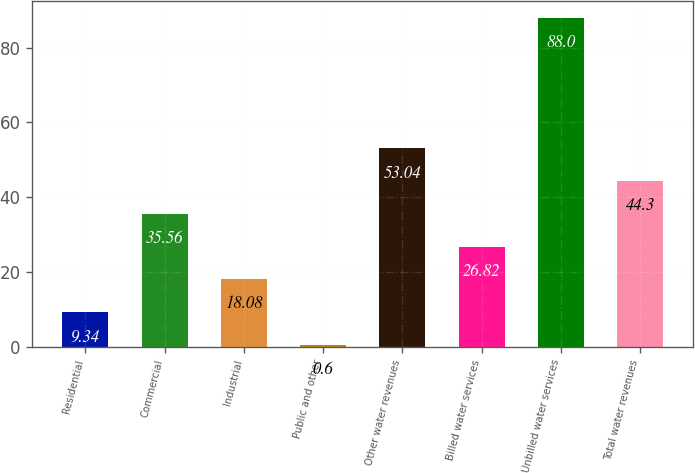<chart> <loc_0><loc_0><loc_500><loc_500><bar_chart><fcel>Residential<fcel>Commercial<fcel>Industrial<fcel>Public and other<fcel>Other water revenues<fcel>Billed water services<fcel>Unbilled water services<fcel>Total water revenues<nl><fcel>9.34<fcel>35.56<fcel>18.08<fcel>0.6<fcel>53.04<fcel>26.82<fcel>88<fcel>44.3<nl></chart> 